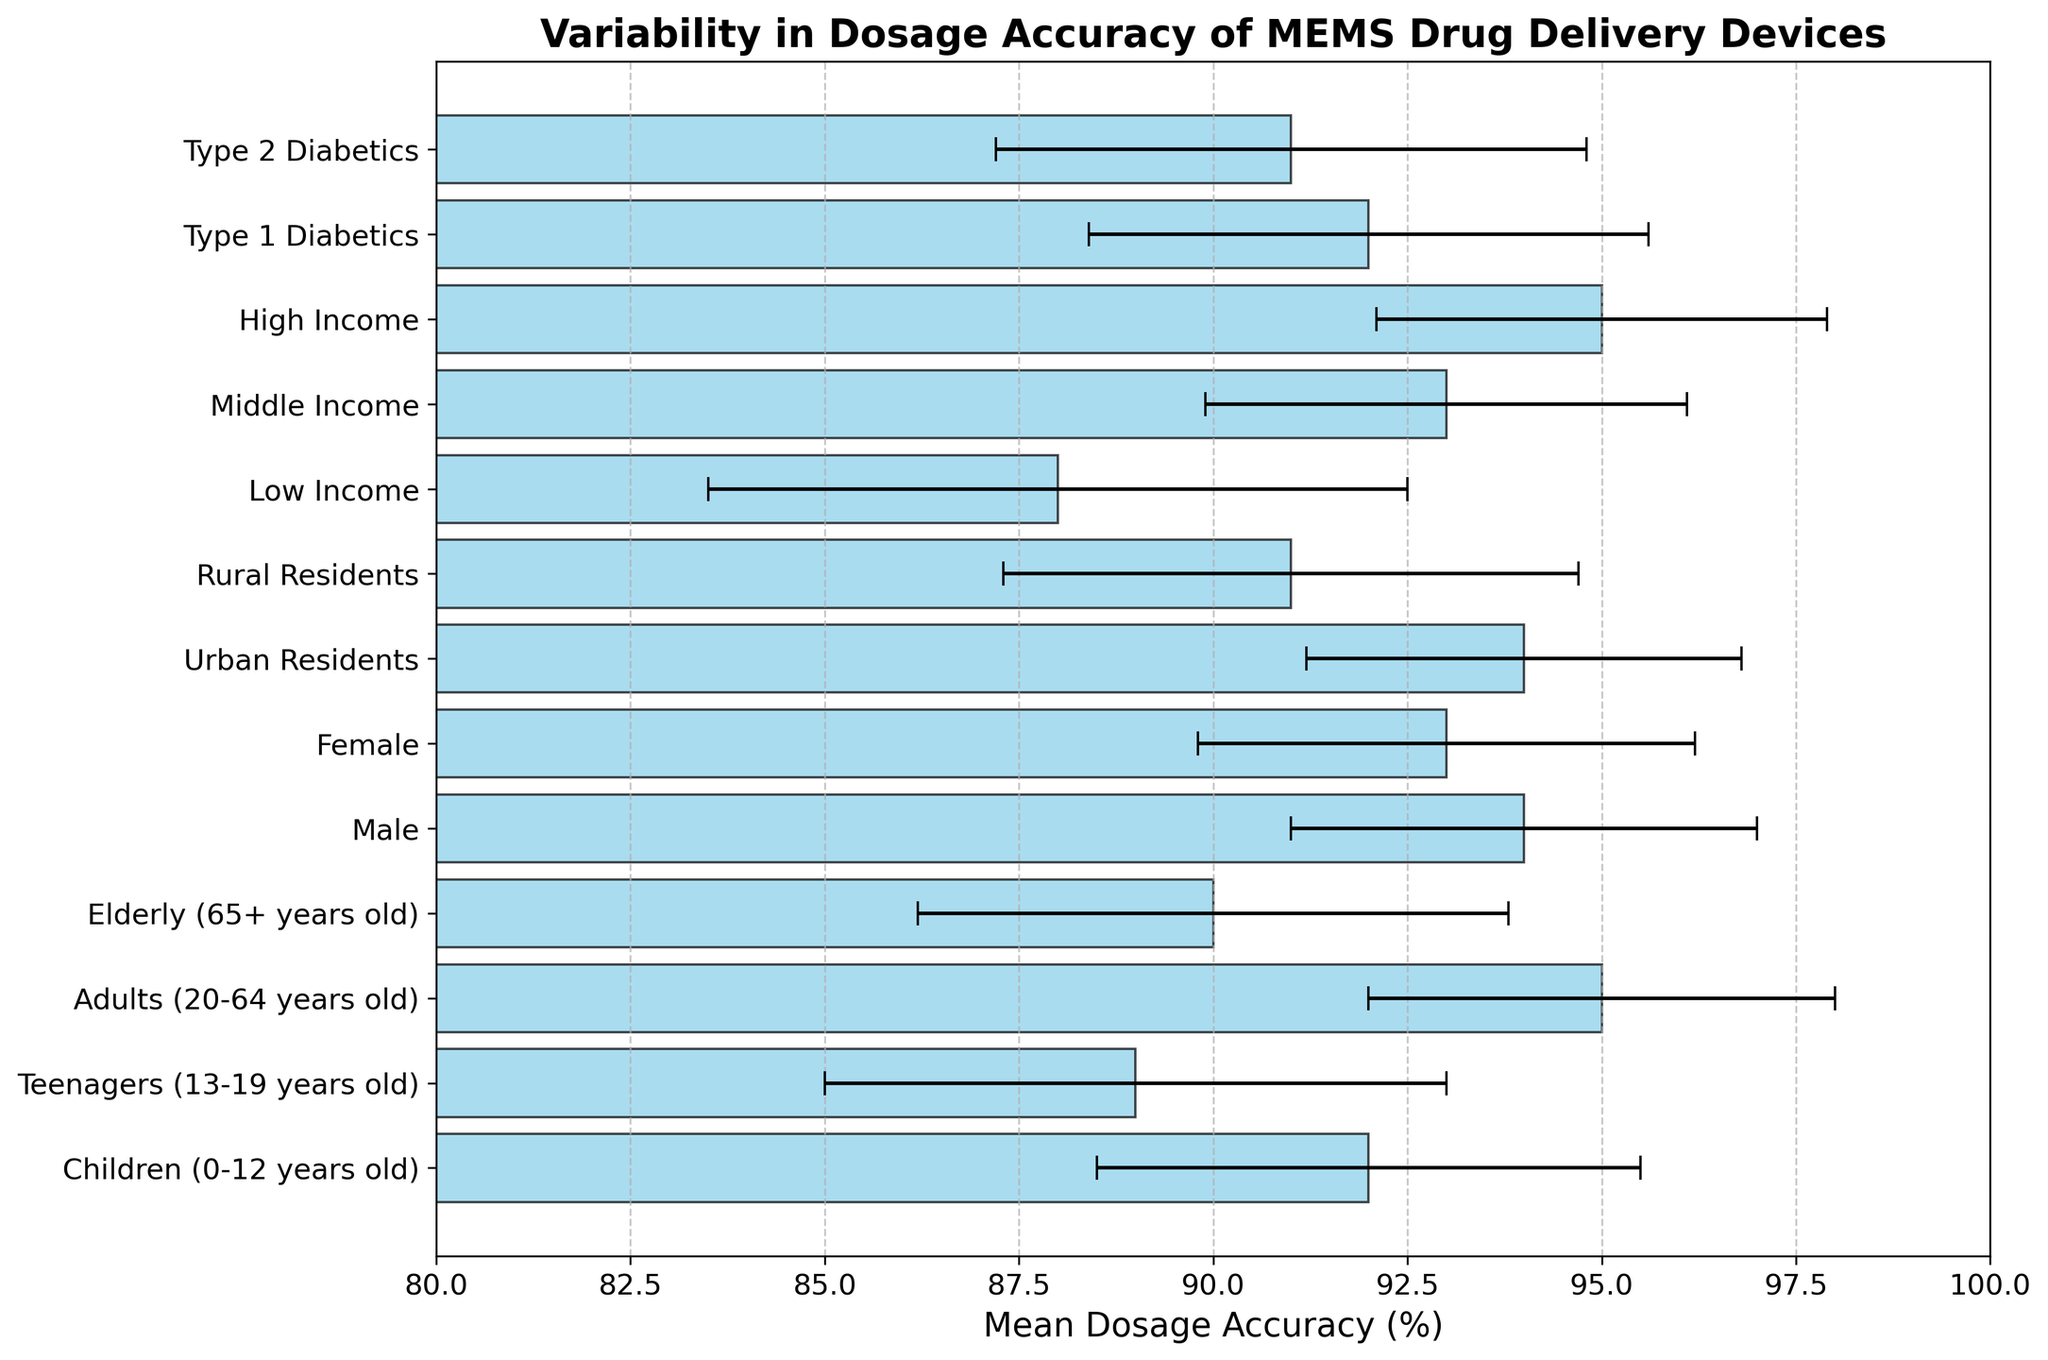Which patient demographic has the highest mean dosage accuracy? Identify which bar has the highest length in the horizontal bar chart. This corresponds to the demographic with the highest mean dosage accuracy.
Answer: Adults (20-64 years old) Which demographic exhibits the highest variability in dosage accuracy? Look for the bar with the largest error bar (standard deviation). This indicates the demographic with the highest variability.
Answer: Low Income Is the accuracy higher for males or females? Compare the lengths of the bars for Males and Females. The bar with the greater length signifies higher accuracy.
Answer: Male What is the range of mean dosage accuracy among urban and rural residents? Evaluate the mean dosage accuracy for both Urban and Rural Residents. The range is the difference between the maximum and minimum values. Urban Residents have 94% and Rural Residents have 91%.
Answer: 3% Which patient demographic has a lower mean dosage accuracy, teenagers or elderly? Compare the lengths of the bars for Teenagers and Elderly. The demographic with the shorter bar has the lower mean dosage accuracy.
Answer: Teenagers How does the dosage accuracy for low-income patients compare to that of high-income patients? Compare the lengths of the bars for Low Income and High Income demographics. The bar representing Low Income is shorter.
Answer: Lower What is the mean dosage accuracy difference between children and type 2 diabetics? Determine the mean dosage accuracy for Children (92%) and Type 2 Diabetics (91%). Subtract the smaller value from the larger value.
Answer: 1% Which group shows a standard deviation of 3.2% in dosage accuracy? Identify the demographic(s) associated with a standard deviation of 3.2%.
Answer: Female Are adults' dosage accuracies more variable than those of elderly patients? Compare the lengths of the error bars (standard deviations) for Adults and Elderly. The group with the longer error bar has higher variability. Elderly patients have a higher standard deviation (3.8%) compared to Adults (3%).
Answer: No Which patient demographic has the mean dosage accuracy closest to 90%? Determine which demographic's mean dosage accuracy is closest to 90% by comparing the absolute differences. Both Elderly and Type 2 Diabetics have mean accuracies of 90% and 91%, respectively.
Answer: Elderly 